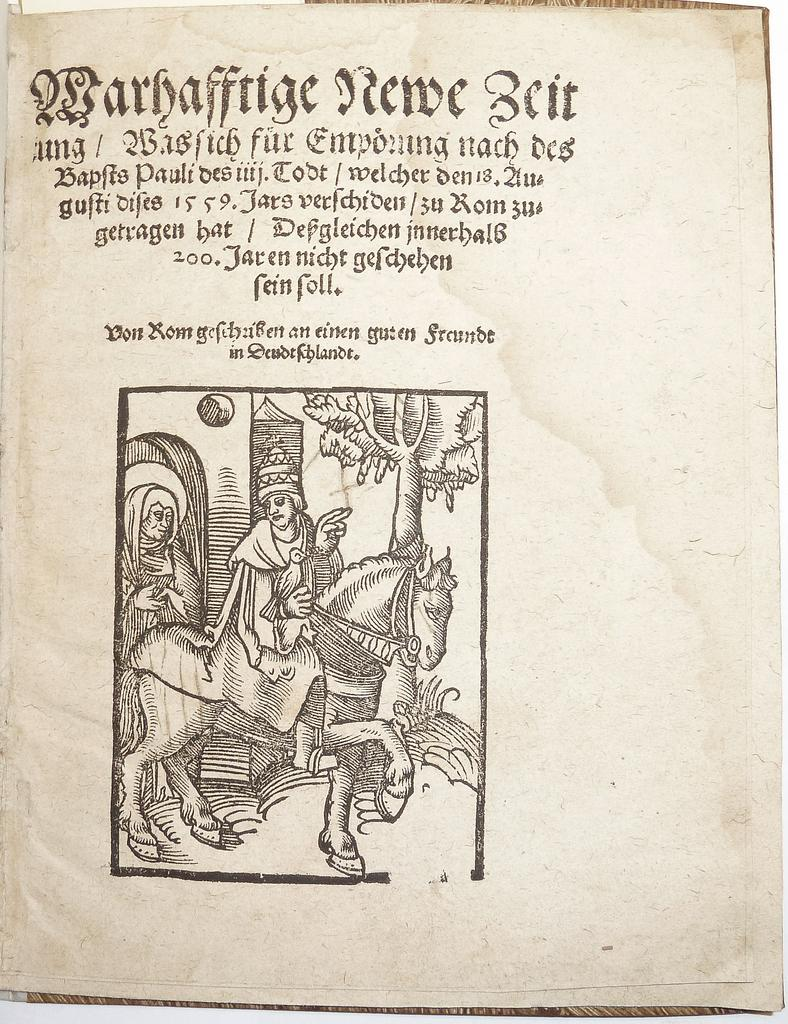What is written on in the image? There is text written on a paper in the image. What else can be seen in the image besides the text? There are drawings in the image. What type of attack is being planned in the image? There is no indication of an attack or any planning in the image; it only contains text and drawings. Can you tell me who gave their approval for the burst in the image? There is no burst or any indication of approval in the image; it only contains text and drawings. 